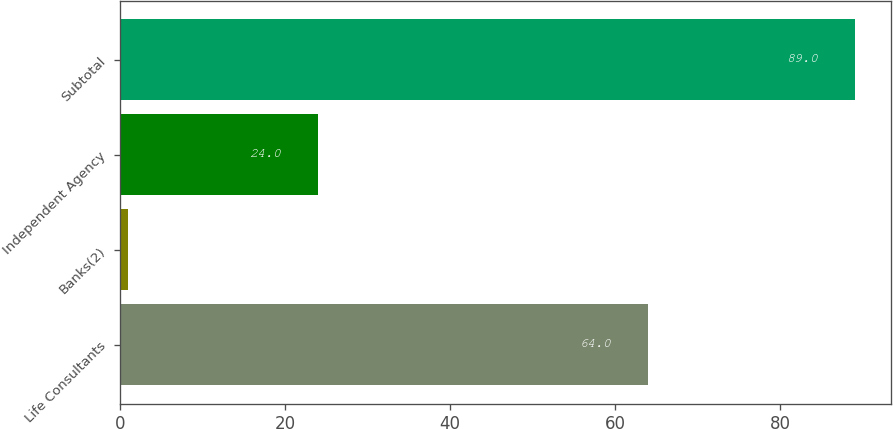Convert chart. <chart><loc_0><loc_0><loc_500><loc_500><bar_chart><fcel>Life Consultants<fcel>Banks(2)<fcel>Independent Agency<fcel>Subtotal<nl><fcel>64<fcel>1<fcel>24<fcel>89<nl></chart> 